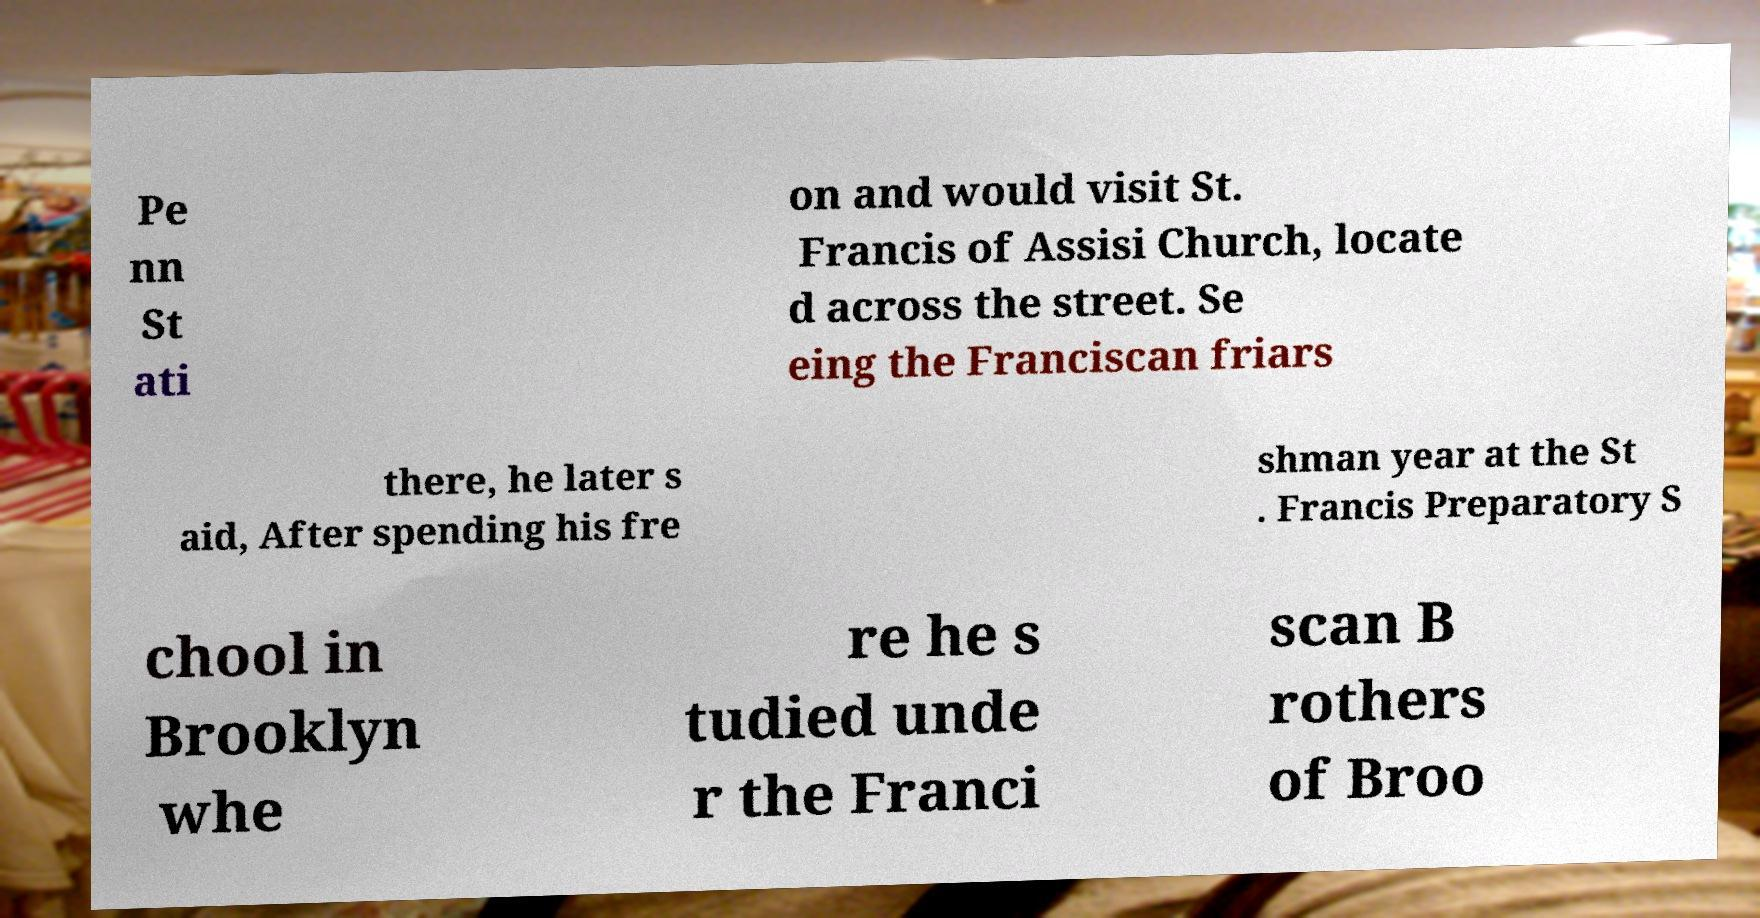Could you assist in decoding the text presented in this image and type it out clearly? Pe nn St ati on and would visit St. Francis of Assisi Church, locate d across the street. Se eing the Franciscan friars there, he later s aid, After spending his fre shman year at the St . Francis Preparatory S chool in Brooklyn whe re he s tudied unde r the Franci scan B rothers of Broo 